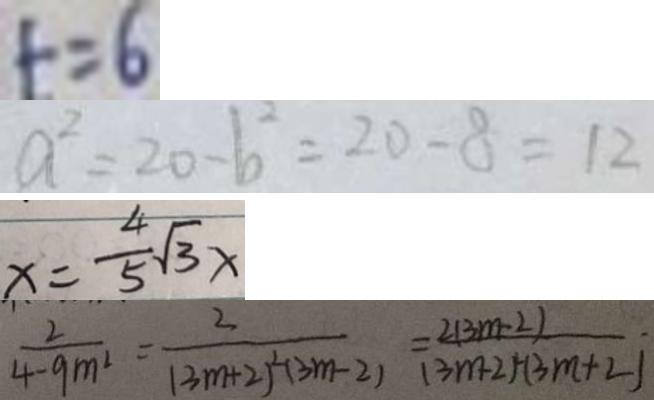Convert formula to latex. <formula><loc_0><loc_0><loc_500><loc_500>t = 6 
 a ^ { 2 } = 2 0 - b ^ { 2 } = 2 0 - 8 = 1 2 
 x = \frac { 4 } { 5 } \sqrt { 3 } x 
 \frac { 2 } { 4 - 9 m ^ { 2 } } = \frac { 2 } { ( 3 m + 2 ) ^ { 2 } ( 3 m - 2 ) } = \frac { 2 ( 3 m - 2 ) } { ( 3 m + 2 ) ^ { 2 } ( 3 m + 2 ) }</formula> 